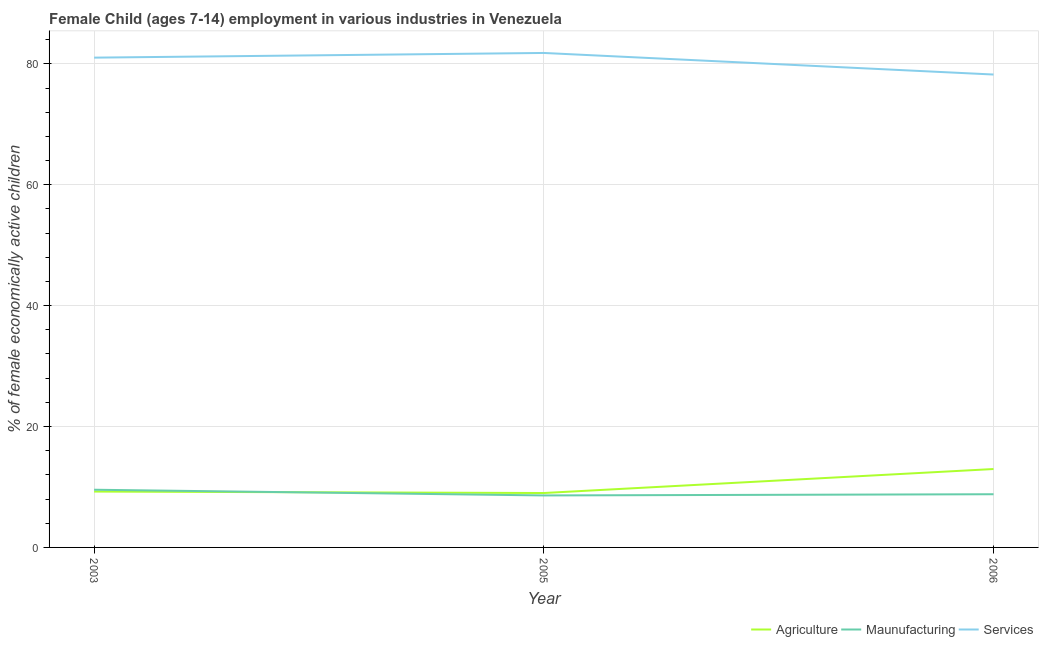How many different coloured lines are there?
Offer a very short reply. 3. Does the line corresponding to percentage of economically active children in services intersect with the line corresponding to percentage of economically active children in agriculture?
Make the answer very short. No. Is the number of lines equal to the number of legend labels?
Give a very brief answer. Yes. Across all years, what is the maximum percentage of economically active children in manufacturing?
Make the answer very short. 9.54. Across all years, what is the minimum percentage of economically active children in services?
Give a very brief answer. 78.23. In which year was the percentage of economically active children in agriculture maximum?
Your response must be concise. 2006. In which year was the percentage of economically active children in services minimum?
Ensure brevity in your answer.  2006. What is the total percentage of economically active children in manufacturing in the graph?
Ensure brevity in your answer.  26.94. What is the difference between the percentage of economically active children in services in 2003 and that in 2005?
Your answer should be compact. -0.78. What is the difference between the percentage of economically active children in services in 2005 and the percentage of economically active children in manufacturing in 2003?
Your answer should be compact. 72.26. What is the average percentage of economically active children in services per year?
Ensure brevity in your answer.  80.35. In the year 2003, what is the difference between the percentage of economically active children in services and percentage of economically active children in agriculture?
Make the answer very short. 71.78. In how many years, is the percentage of economically active children in services greater than 4 %?
Offer a very short reply. 3. What is the ratio of the percentage of economically active children in services in 2005 to that in 2006?
Offer a terse response. 1.05. Is the percentage of economically active children in manufacturing in 2003 less than that in 2006?
Your answer should be very brief. No. Is the difference between the percentage of economically active children in services in 2003 and 2006 greater than the difference between the percentage of economically active children in manufacturing in 2003 and 2006?
Your answer should be compact. Yes. What is the difference between the highest and the second highest percentage of economically active children in manufacturing?
Your answer should be compact. 0.74. What is the difference between the highest and the lowest percentage of economically active children in manufacturing?
Keep it short and to the point. 0.94. In how many years, is the percentage of economically active children in services greater than the average percentage of economically active children in services taken over all years?
Give a very brief answer. 2. Does the percentage of economically active children in services monotonically increase over the years?
Your answer should be compact. No. Is the percentage of economically active children in manufacturing strictly less than the percentage of economically active children in services over the years?
Provide a succinct answer. Yes. How many years are there in the graph?
Provide a short and direct response. 3. Where does the legend appear in the graph?
Your response must be concise. Bottom right. What is the title of the graph?
Ensure brevity in your answer.  Female Child (ages 7-14) employment in various industries in Venezuela. What is the label or title of the Y-axis?
Offer a very short reply. % of female economically active children. What is the % of female economically active children in Agriculture in 2003?
Your answer should be very brief. 9.24. What is the % of female economically active children of Maunufacturing in 2003?
Your response must be concise. 9.54. What is the % of female economically active children of Services in 2003?
Provide a succinct answer. 81.02. What is the % of female economically active children in Maunufacturing in 2005?
Your response must be concise. 8.6. What is the % of female economically active children in Services in 2005?
Your answer should be very brief. 81.8. What is the % of female economically active children in Agriculture in 2006?
Provide a succinct answer. 12.97. What is the % of female economically active children of Maunufacturing in 2006?
Offer a very short reply. 8.8. What is the % of female economically active children of Services in 2006?
Make the answer very short. 78.23. Across all years, what is the maximum % of female economically active children in Agriculture?
Your response must be concise. 12.97. Across all years, what is the maximum % of female economically active children of Maunufacturing?
Provide a short and direct response. 9.54. Across all years, what is the maximum % of female economically active children in Services?
Make the answer very short. 81.8. Across all years, what is the minimum % of female economically active children in Maunufacturing?
Ensure brevity in your answer.  8.6. Across all years, what is the minimum % of female economically active children in Services?
Give a very brief answer. 78.23. What is the total % of female economically active children in Agriculture in the graph?
Make the answer very short. 31.21. What is the total % of female economically active children of Maunufacturing in the graph?
Your response must be concise. 26.94. What is the total % of female economically active children in Services in the graph?
Keep it short and to the point. 241.05. What is the difference between the % of female economically active children of Agriculture in 2003 and that in 2005?
Make the answer very short. 0.24. What is the difference between the % of female economically active children in Maunufacturing in 2003 and that in 2005?
Provide a short and direct response. 0.94. What is the difference between the % of female economically active children of Services in 2003 and that in 2005?
Ensure brevity in your answer.  -0.78. What is the difference between the % of female economically active children in Agriculture in 2003 and that in 2006?
Offer a terse response. -3.73. What is the difference between the % of female economically active children in Maunufacturing in 2003 and that in 2006?
Offer a terse response. 0.74. What is the difference between the % of female economically active children of Services in 2003 and that in 2006?
Provide a succinct answer. 2.79. What is the difference between the % of female economically active children of Agriculture in 2005 and that in 2006?
Offer a terse response. -3.97. What is the difference between the % of female economically active children of Services in 2005 and that in 2006?
Provide a succinct answer. 3.57. What is the difference between the % of female economically active children of Agriculture in 2003 and the % of female economically active children of Maunufacturing in 2005?
Ensure brevity in your answer.  0.64. What is the difference between the % of female economically active children of Agriculture in 2003 and the % of female economically active children of Services in 2005?
Give a very brief answer. -72.56. What is the difference between the % of female economically active children of Maunufacturing in 2003 and the % of female economically active children of Services in 2005?
Keep it short and to the point. -72.26. What is the difference between the % of female economically active children of Agriculture in 2003 and the % of female economically active children of Maunufacturing in 2006?
Your answer should be compact. 0.44. What is the difference between the % of female economically active children in Agriculture in 2003 and the % of female economically active children in Services in 2006?
Your response must be concise. -68.99. What is the difference between the % of female economically active children of Maunufacturing in 2003 and the % of female economically active children of Services in 2006?
Make the answer very short. -68.69. What is the difference between the % of female economically active children of Agriculture in 2005 and the % of female economically active children of Services in 2006?
Offer a terse response. -69.23. What is the difference between the % of female economically active children in Maunufacturing in 2005 and the % of female economically active children in Services in 2006?
Ensure brevity in your answer.  -69.63. What is the average % of female economically active children of Agriculture per year?
Your response must be concise. 10.4. What is the average % of female economically active children of Maunufacturing per year?
Your answer should be very brief. 8.98. What is the average % of female economically active children in Services per year?
Give a very brief answer. 80.35. In the year 2003, what is the difference between the % of female economically active children of Agriculture and % of female economically active children of Maunufacturing?
Your answer should be very brief. -0.3. In the year 2003, what is the difference between the % of female economically active children in Agriculture and % of female economically active children in Services?
Give a very brief answer. -71.78. In the year 2003, what is the difference between the % of female economically active children of Maunufacturing and % of female economically active children of Services?
Give a very brief answer. -71.48. In the year 2005, what is the difference between the % of female economically active children in Agriculture and % of female economically active children in Services?
Keep it short and to the point. -72.8. In the year 2005, what is the difference between the % of female economically active children in Maunufacturing and % of female economically active children in Services?
Provide a succinct answer. -73.2. In the year 2006, what is the difference between the % of female economically active children in Agriculture and % of female economically active children in Maunufacturing?
Make the answer very short. 4.17. In the year 2006, what is the difference between the % of female economically active children in Agriculture and % of female economically active children in Services?
Provide a short and direct response. -65.26. In the year 2006, what is the difference between the % of female economically active children of Maunufacturing and % of female economically active children of Services?
Keep it short and to the point. -69.43. What is the ratio of the % of female economically active children of Agriculture in 2003 to that in 2005?
Offer a terse response. 1.03. What is the ratio of the % of female economically active children of Maunufacturing in 2003 to that in 2005?
Offer a very short reply. 1.11. What is the ratio of the % of female economically active children of Services in 2003 to that in 2005?
Offer a very short reply. 0.99. What is the ratio of the % of female economically active children in Agriculture in 2003 to that in 2006?
Your answer should be compact. 0.71. What is the ratio of the % of female economically active children in Maunufacturing in 2003 to that in 2006?
Ensure brevity in your answer.  1.08. What is the ratio of the % of female economically active children in Services in 2003 to that in 2006?
Keep it short and to the point. 1.04. What is the ratio of the % of female economically active children in Agriculture in 2005 to that in 2006?
Your answer should be very brief. 0.69. What is the ratio of the % of female economically active children of Maunufacturing in 2005 to that in 2006?
Ensure brevity in your answer.  0.98. What is the ratio of the % of female economically active children in Services in 2005 to that in 2006?
Make the answer very short. 1.05. What is the difference between the highest and the second highest % of female economically active children of Agriculture?
Your answer should be very brief. 3.73. What is the difference between the highest and the second highest % of female economically active children of Maunufacturing?
Make the answer very short. 0.74. What is the difference between the highest and the second highest % of female economically active children of Services?
Ensure brevity in your answer.  0.78. What is the difference between the highest and the lowest % of female economically active children of Agriculture?
Keep it short and to the point. 3.97. What is the difference between the highest and the lowest % of female economically active children of Maunufacturing?
Give a very brief answer. 0.94. What is the difference between the highest and the lowest % of female economically active children in Services?
Offer a terse response. 3.57. 